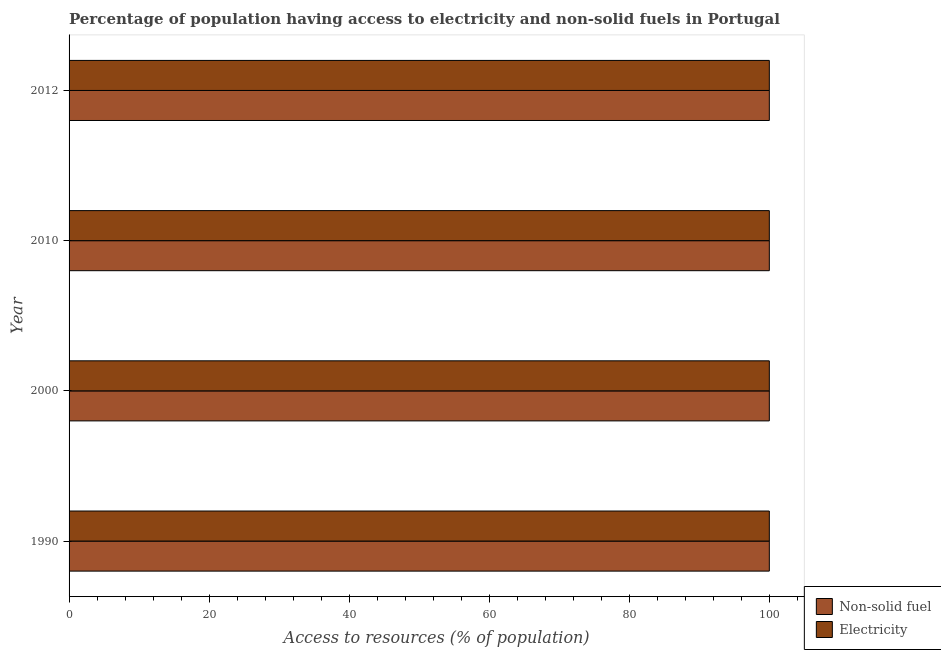How many groups of bars are there?
Your response must be concise. 4. How many bars are there on the 1st tick from the top?
Offer a terse response. 2. How many bars are there on the 1st tick from the bottom?
Offer a very short reply. 2. What is the label of the 2nd group of bars from the top?
Offer a very short reply. 2010. What is the percentage of population having access to electricity in 2010?
Your answer should be very brief. 100. Across all years, what is the maximum percentage of population having access to non-solid fuel?
Provide a succinct answer. 100. Across all years, what is the minimum percentage of population having access to electricity?
Offer a terse response. 100. In which year was the percentage of population having access to non-solid fuel minimum?
Give a very brief answer. 1990. What is the total percentage of population having access to electricity in the graph?
Provide a short and direct response. 400. What is the difference between the percentage of population having access to non-solid fuel in 1990 and that in 2010?
Your answer should be compact. 0. Is the percentage of population having access to electricity in 1990 less than that in 2012?
Your answer should be very brief. No. Is the difference between the percentage of population having access to electricity in 2000 and 2012 greater than the difference between the percentage of population having access to non-solid fuel in 2000 and 2012?
Your answer should be very brief. No. In how many years, is the percentage of population having access to non-solid fuel greater than the average percentage of population having access to non-solid fuel taken over all years?
Ensure brevity in your answer.  0. What does the 2nd bar from the top in 1990 represents?
Give a very brief answer. Non-solid fuel. What does the 2nd bar from the bottom in 2012 represents?
Provide a succinct answer. Electricity. How many bars are there?
Offer a very short reply. 8. How many years are there in the graph?
Provide a succinct answer. 4. What is the difference between two consecutive major ticks on the X-axis?
Your answer should be very brief. 20. How many legend labels are there?
Give a very brief answer. 2. What is the title of the graph?
Your answer should be compact. Percentage of population having access to electricity and non-solid fuels in Portugal. What is the label or title of the X-axis?
Keep it short and to the point. Access to resources (% of population). What is the Access to resources (% of population) of Non-solid fuel in 2000?
Give a very brief answer. 100. What is the Access to resources (% of population) of Electricity in 2000?
Offer a very short reply. 100. What is the Access to resources (% of population) of Non-solid fuel in 2012?
Make the answer very short. 100. What is the Access to resources (% of population) of Electricity in 2012?
Make the answer very short. 100. Across all years, what is the maximum Access to resources (% of population) of Non-solid fuel?
Offer a very short reply. 100. Across all years, what is the minimum Access to resources (% of population) in Non-solid fuel?
Make the answer very short. 100. What is the total Access to resources (% of population) in Non-solid fuel in the graph?
Your answer should be compact. 400. What is the difference between the Access to resources (% of population) in Electricity in 1990 and that in 2000?
Keep it short and to the point. 0. What is the difference between the Access to resources (% of population) in Non-solid fuel in 1990 and that in 2010?
Offer a terse response. 0. What is the difference between the Access to resources (% of population) of Electricity in 1990 and that in 2010?
Your response must be concise. 0. What is the difference between the Access to resources (% of population) of Non-solid fuel in 1990 and that in 2012?
Your answer should be compact. 0. What is the difference between the Access to resources (% of population) in Electricity in 1990 and that in 2012?
Keep it short and to the point. 0. What is the difference between the Access to resources (% of population) in Non-solid fuel in 2010 and that in 2012?
Offer a terse response. 0. What is the difference between the Access to resources (% of population) of Non-solid fuel in 1990 and the Access to resources (% of population) of Electricity in 2000?
Make the answer very short. 0. What is the difference between the Access to resources (% of population) of Non-solid fuel in 1990 and the Access to resources (% of population) of Electricity in 2010?
Provide a succinct answer. 0. What is the difference between the Access to resources (% of population) of Non-solid fuel in 1990 and the Access to resources (% of population) of Electricity in 2012?
Provide a succinct answer. 0. What is the difference between the Access to resources (% of population) in Non-solid fuel in 2000 and the Access to resources (% of population) in Electricity in 2012?
Provide a short and direct response. 0. What is the average Access to resources (% of population) of Non-solid fuel per year?
Ensure brevity in your answer.  100. What is the average Access to resources (% of population) of Electricity per year?
Keep it short and to the point. 100. In the year 1990, what is the difference between the Access to resources (% of population) of Non-solid fuel and Access to resources (% of population) of Electricity?
Ensure brevity in your answer.  0. In the year 2010, what is the difference between the Access to resources (% of population) in Non-solid fuel and Access to resources (% of population) in Electricity?
Your response must be concise. 0. In the year 2012, what is the difference between the Access to resources (% of population) of Non-solid fuel and Access to resources (% of population) of Electricity?
Offer a terse response. 0. What is the ratio of the Access to resources (% of population) in Electricity in 1990 to that in 2010?
Offer a very short reply. 1. What is the ratio of the Access to resources (% of population) of Non-solid fuel in 1990 to that in 2012?
Your response must be concise. 1. What is the ratio of the Access to resources (% of population) in Electricity in 1990 to that in 2012?
Your answer should be very brief. 1. What is the ratio of the Access to resources (% of population) in Non-solid fuel in 2000 to that in 2012?
Keep it short and to the point. 1. What is the ratio of the Access to resources (% of population) in Non-solid fuel in 2010 to that in 2012?
Offer a very short reply. 1. What is the ratio of the Access to resources (% of population) of Electricity in 2010 to that in 2012?
Provide a short and direct response. 1. What is the difference between the highest and the second highest Access to resources (% of population) in Non-solid fuel?
Offer a terse response. 0. What is the difference between the highest and the lowest Access to resources (% of population) in Electricity?
Provide a succinct answer. 0. 